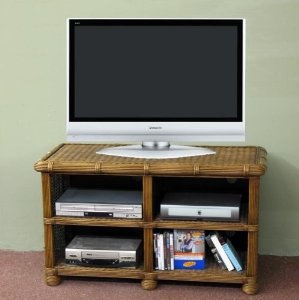Describe the objects in this image and their specific colors. I can see tv in beige, black, lightgray, and darkgray tones, book in beige, darkgray, gray, and lavender tones, book in beige, black, lightblue, and blue tones, book in beige, white, darkgray, gray, and black tones, and book in beige, gray, black, and darkgray tones in this image. 